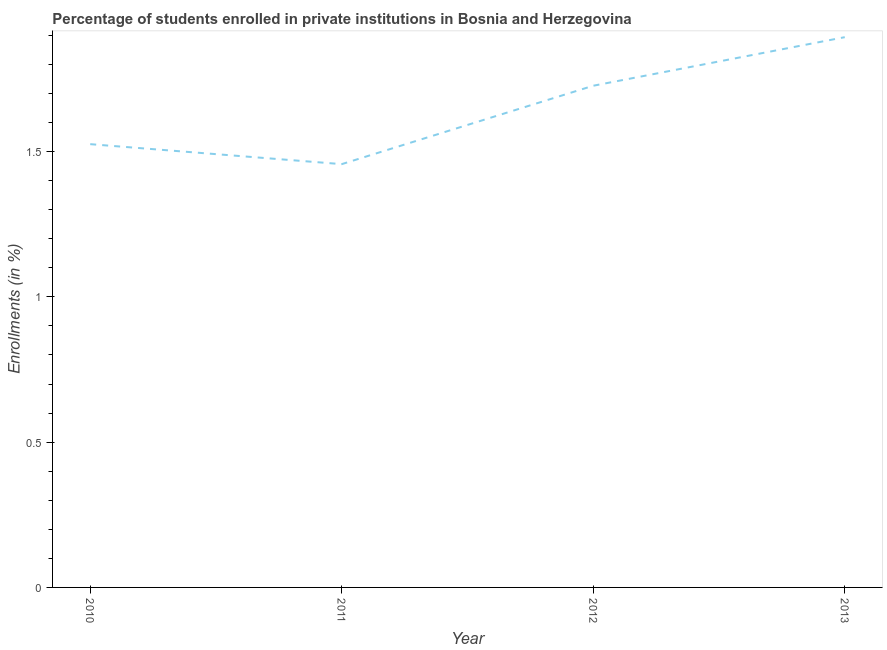What is the enrollments in private institutions in 2010?
Offer a very short reply. 1.53. Across all years, what is the maximum enrollments in private institutions?
Provide a succinct answer. 1.89. Across all years, what is the minimum enrollments in private institutions?
Your answer should be very brief. 1.46. What is the sum of the enrollments in private institutions?
Keep it short and to the point. 6.6. What is the difference between the enrollments in private institutions in 2010 and 2013?
Your answer should be very brief. -0.37. What is the average enrollments in private institutions per year?
Your answer should be very brief. 1.65. What is the median enrollments in private institutions?
Offer a very short reply. 1.63. In how many years, is the enrollments in private institutions greater than 1.3 %?
Your answer should be very brief. 4. What is the ratio of the enrollments in private institutions in 2010 to that in 2012?
Ensure brevity in your answer.  0.88. Is the enrollments in private institutions in 2010 less than that in 2011?
Ensure brevity in your answer.  No. What is the difference between the highest and the second highest enrollments in private institutions?
Your response must be concise. 0.17. What is the difference between the highest and the lowest enrollments in private institutions?
Your answer should be very brief. 0.44. In how many years, is the enrollments in private institutions greater than the average enrollments in private institutions taken over all years?
Provide a short and direct response. 2. Does the enrollments in private institutions monotonically increase over the years?
Make the answer very short. No. How many lines are there?
Provide a succinct answer. 1. How many years are there in the graph?
Provide a succinct answer. 4. Does the graph contain grids?
Your answer should be compact. No. What is the title of the graph?
Offer a very short reply. Percentage of students enrolled in private institutions in Bosnia and Herzegovina. What is the label or title of the Y-axis?
Give a very brief answer. Enrollments (in %). What is the Enrollments (in %) of 2010?
Keep it short and to the point. 1.53. What is the Enrollments (in %) of 2011?
Provide a succinct answer. 1.46. What is the Enrollments (in %) in 2012?
Offer a very short reply. 1.73. What is the Enrollments (in %) of 2013?
Offer a terse response. 1.89. What is the difference between the Enrollments (in %) in 2010 and 2011?
Your response must be concise. 0.07. What is the difference between the Enrollments (in %) in 2010 and 2012?
Your answer should be compact. -0.2. What is the difference between the Enrollments (in %) in 2010 and 2013?
Provide a succinct answer. -0.37. What is the difference between the Enrollments (in %) in 2011 and 2012?
Give a very brief answer. -0.27. What is the difference between the Enrollments (in %) in 2011 and 2013?
Keep it short and to the point. -0.44. What is the difference between the Enrollments (in %) in 2012 and 2013?
Provide a short and direct response. -0.17. What is the ratio of the Enrollments (in %) in 2010 to that in 2011?
Provide a short and direct response. 1.05. What is the ratio of the Enrollments (in %) in 2010 to that in 2012?
Ensure brevity in your answer.  0.88. What is the ratio of the Enrollments (in %) in 2010 to that in 2013?
Ensure brevity in your answer.  0.81. What is the ratio of the Enrollments (in %) in 2011 to that in 2012?
Make the answer very short. 0.84. What is the ratio of the Enrollments (in %) in 2011 to that in 2013?
Your answer should be compact. 0.77. What is the ratio of the Enrollments (in %) in 2012 to that in 2013?
Your answer should be compact. 0.91. 